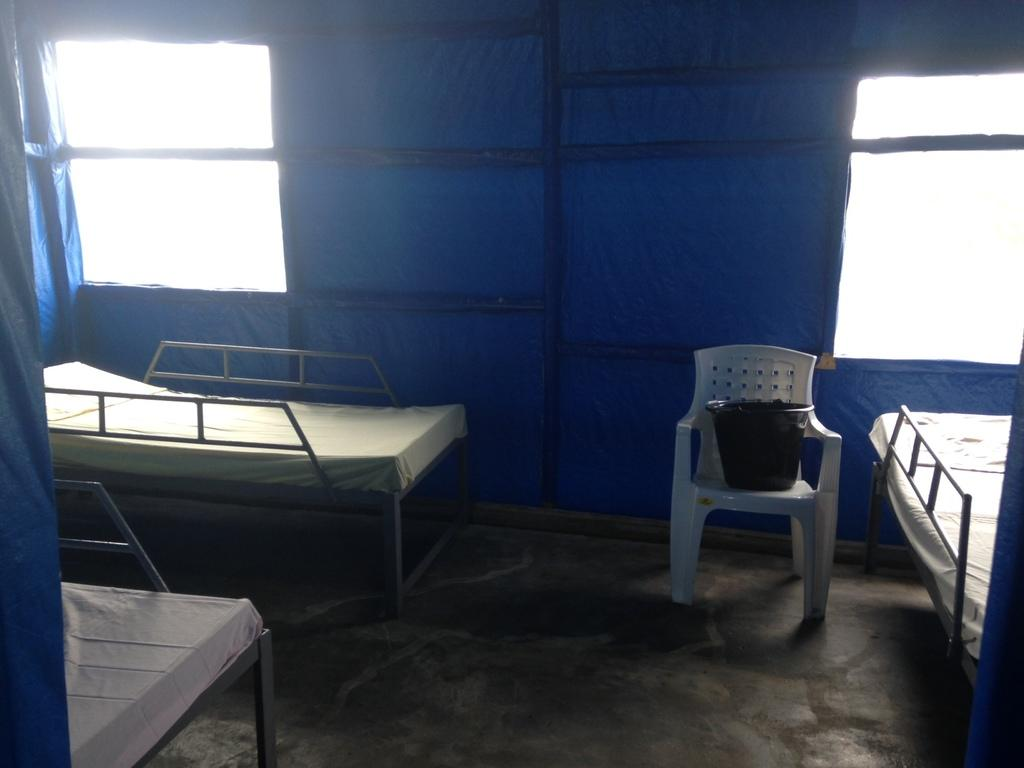How many beds are visible in the image? There are three beds in the image. What is on the chair in the image? There is an object on a chair in the image. What type of structure can be seen in the image? There are a few poles in the image. What can be seen through the windows in the image? There are windows in the closed tent in the image. What type of popcorn can be seen in the frame in the image? There is no popcorn or frame present in the image. What type of ball is visible in the image? There is no ball visible in the image. 